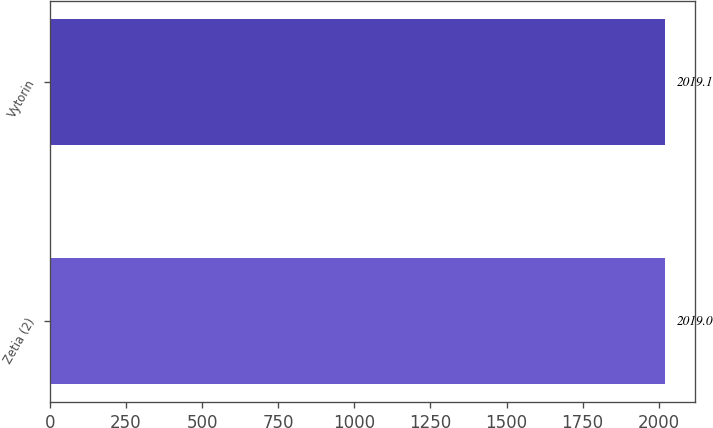<chart> <loc_0><loc_0><loc_500><loc_500><bar_chart><fcel>Zetia (2)<fcel>Vytorin<nl><fcel>2019<fcel>2019.1<nl></chart> 